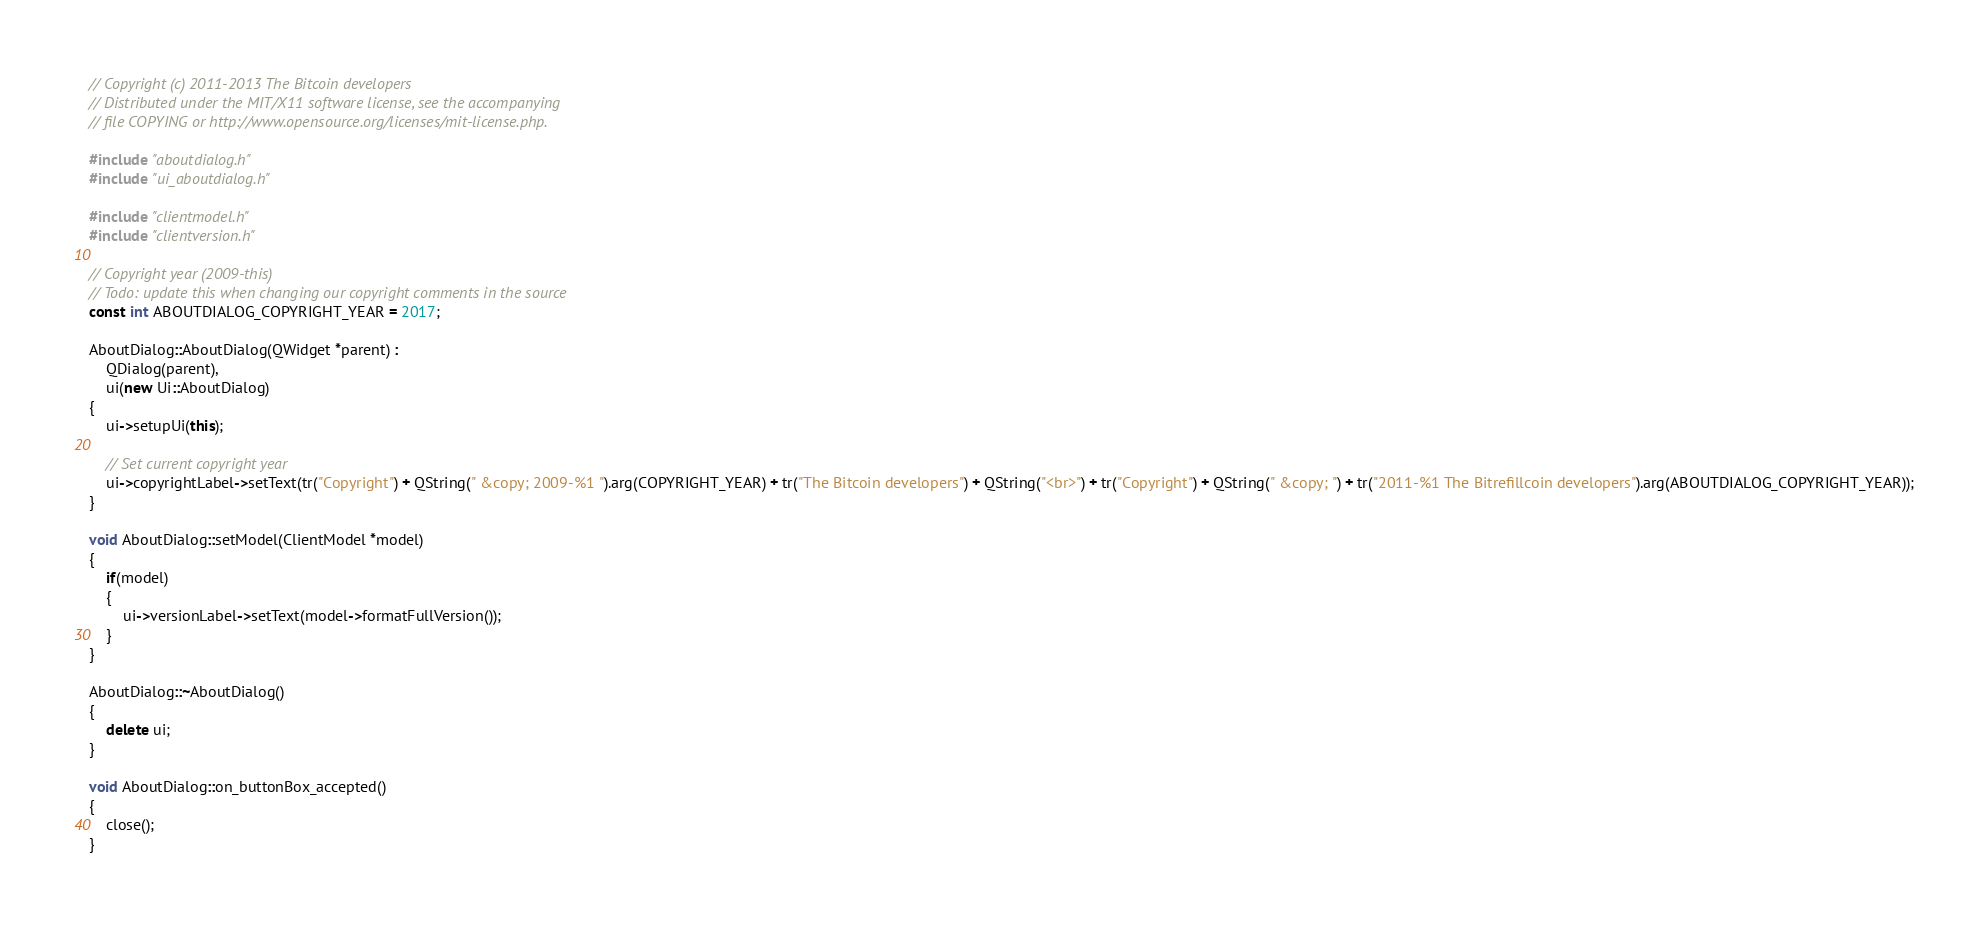<code> <loc_0><loc_0><loc_500><loc_500><_C++_>// Copyright (c) 2011-2013 The Bitcoin developers
// Distributed under the MIT/X11 software license, see the accompanying
// file COPYING or http://www.opensource.org/licenses/mit-license.php.

#include "aboutdialog.h"
#include "ui_aboutdialog.h"

#include "clientmodel.h"
#include "clientversion.h"

// Copyright year (2009-this)
// Todo: update this when changing our copyright comments in the source
const int ABOUTDIALOG_COPYRIGHT_YEAR = 2017;

AboutDialog::AboutDialog(QWidget *parent) :
    QDialog(parent),
    ui(new Ui::AboutDialog)
{
    ui->setupUi(this);

    // Set current copyright year
    ui->copyrightLabel->setText(tr("Copyright") + QString(" &copy; 2009-%1 ").arg(COPYRIGHT_YEAR) + tr("The Bitcoin developers") + QString("<br>") + tr("Copyright") + QString(" &copy; ") + tr("2011-%1 The Bitrefillcoin developers").arg(ABOUTDIALOG_COPYRIGHT_YEAR));
}

void AboutDialog::setModel(ClientModel *model)
{
    if(model)
    {
        ui->versionLabel->setText(model->formatFullVersion());
    }
}

AboutDialog::~AboutDialog()
{
    delete ui;
}

void AboutDialog::on_buttonBox_accepted()
{
    close();
}
</code> 